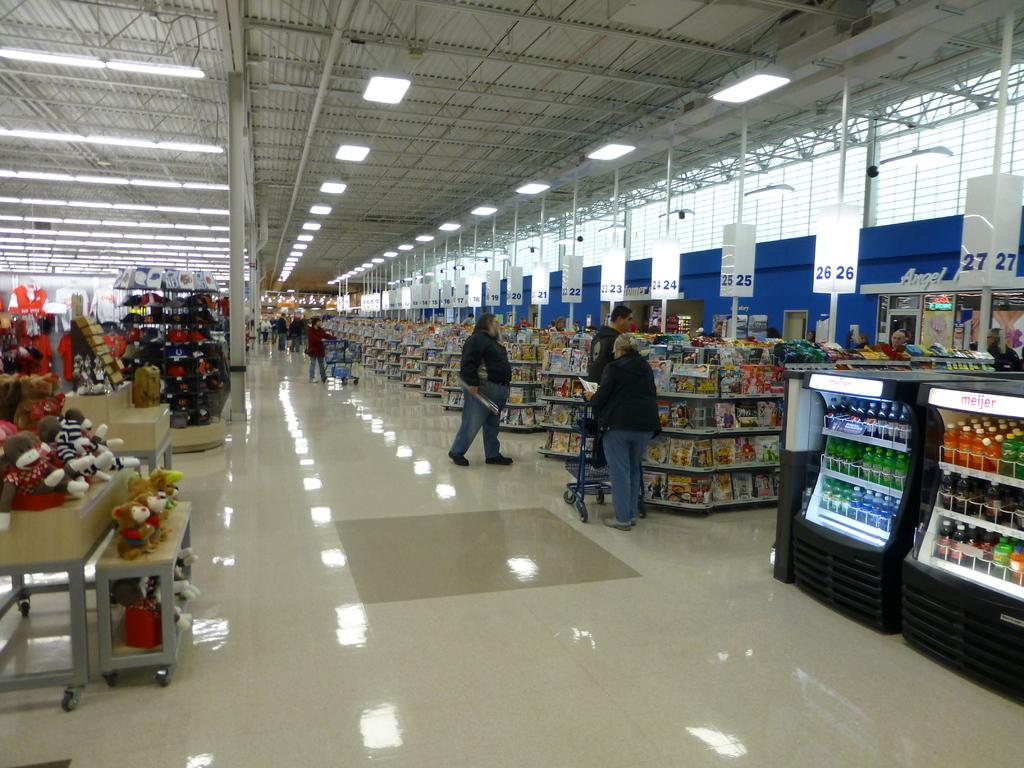<image>
Write a terse but informative summary of the picture. A line is building in a grocery store at cash register 26. 